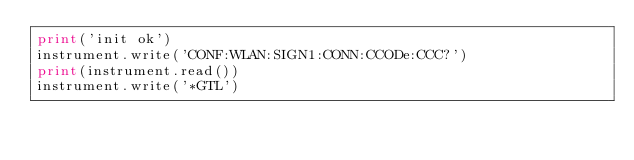Convert code to text. <code><loc_0><loc_0><loc_500><loc_500><_Python_>print('init ok')
instrument.write('CONF:WLAN:SIGN1:CONN:CCODe:CCC?')
print(instrument.read())
instrument.write('*GTL')</code> 